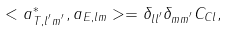<formula> <loc_0><loc_0><loc_500><loc_500>< a _ { T , l ^ { ^ { \prime } } m ^ { ^ { \prime } } } ^ { * } , a _ { E , l m } > = \delta _ { l l ^ { ^ { \prime } } } \delta _ { m m ^ { ^ { \prime } } } C _ { C l } ,</formula> 